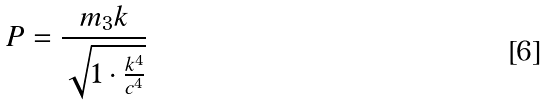Convert formula to latex. <formula><loc_0><loc_0><loc_500><loc_500>P = \frac { m _ { 3 } k } { \sqrt { 1 \cdot \frac { k ^ { 4 } } { c ^ { 4 } } } }</formula> 